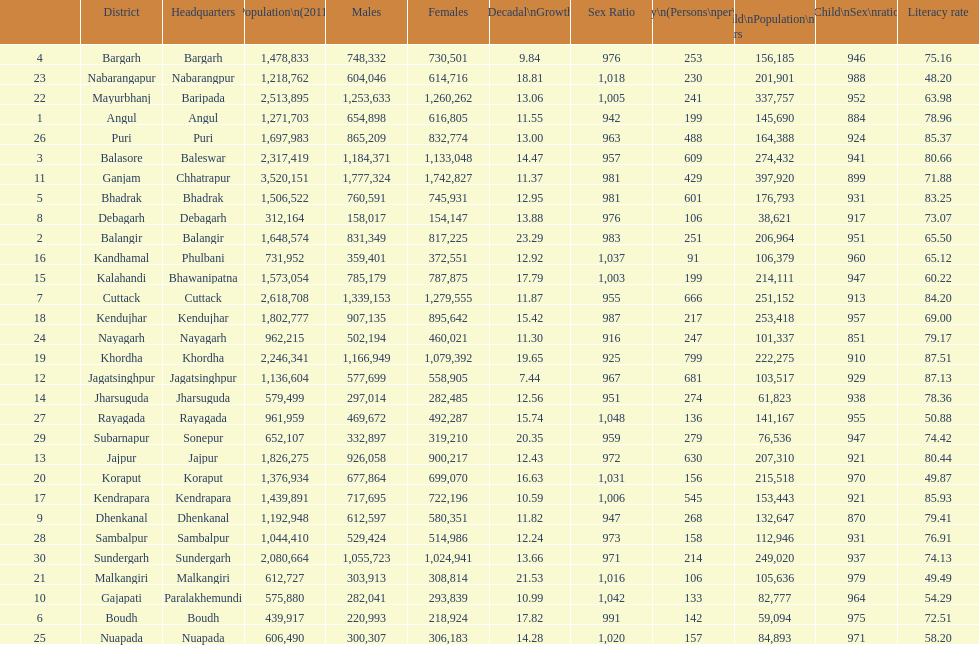Which district had least population growth from 2001-2011? Jagatsinghpur. 